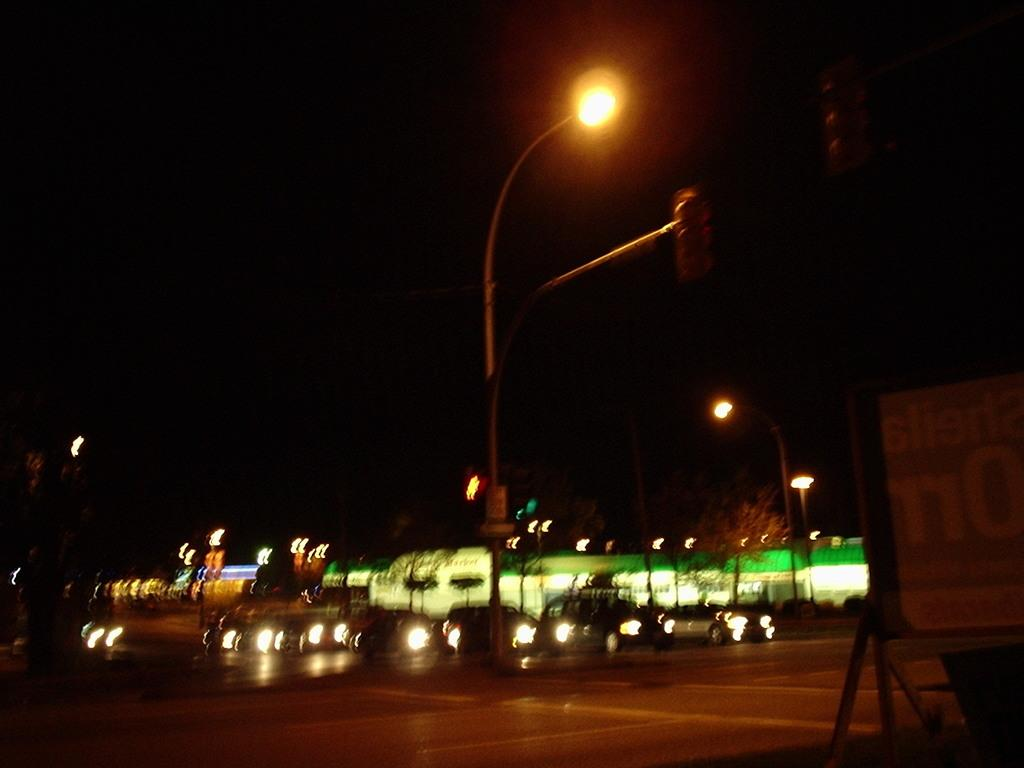What type of vehicles can be seen in the image? There are cars in the image. What structures are present in the image? There are buildings in the image. What type of illumination is visible in the image? There are lights in the image. What type of vegetation is present in the image? There are trees in the image. What part of the natural environment is visible in the image? The sky is visible in the image. How would you describe the overall lighting in the image? The image is dark. What type of quiver can be seen in the image? There is no quiver present in the image. What level of experience does the beginner have in the image? There is no indication of a beginner or any experience level in the image. 